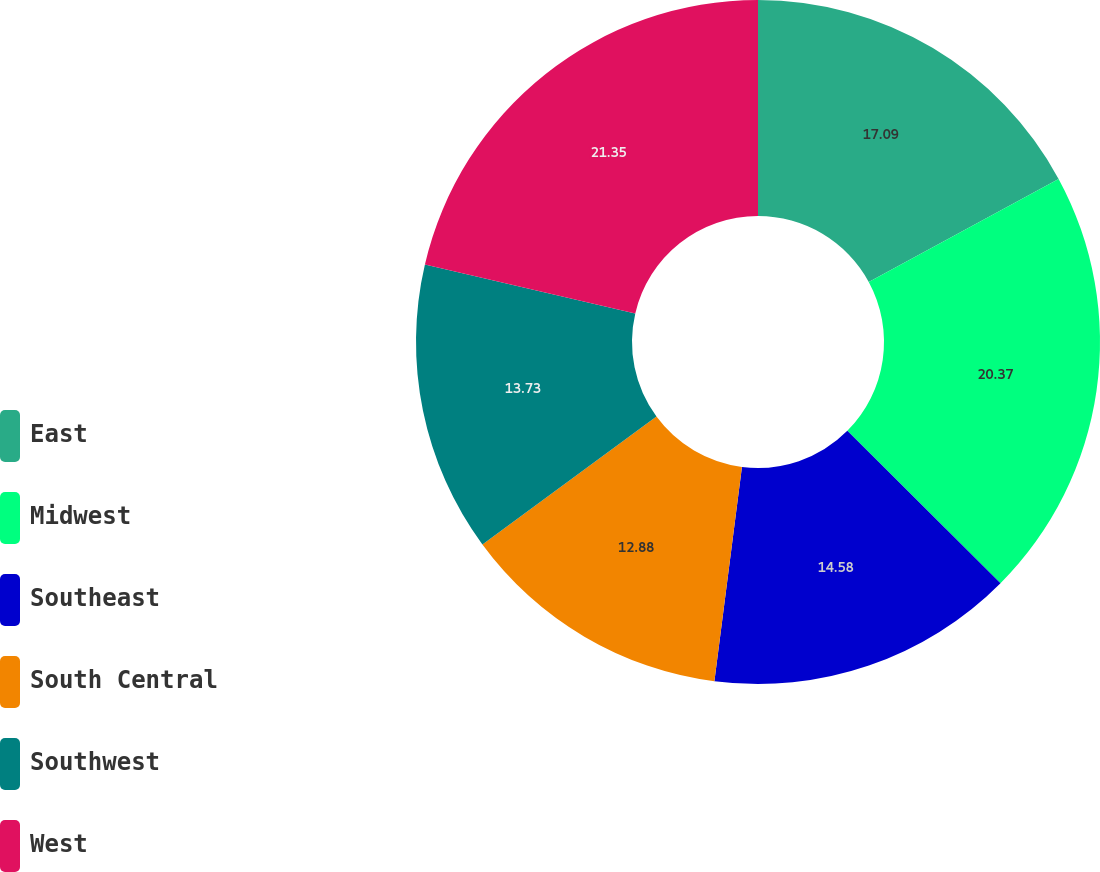Convert chart to OTSL. <chart><loc_0><loc_0><loc_500><loc_500><pie_chart><fcel>East<fcel>Midwest<fcel>Southeast<fcel>South Central<fcel>Southwest<fcel>West<nl><fcel>17.09%<fcel>20.37%<fcel>14.58%<fcel>12.88%<fcel>13.73%<fcel>21.36%<nl></chart> 